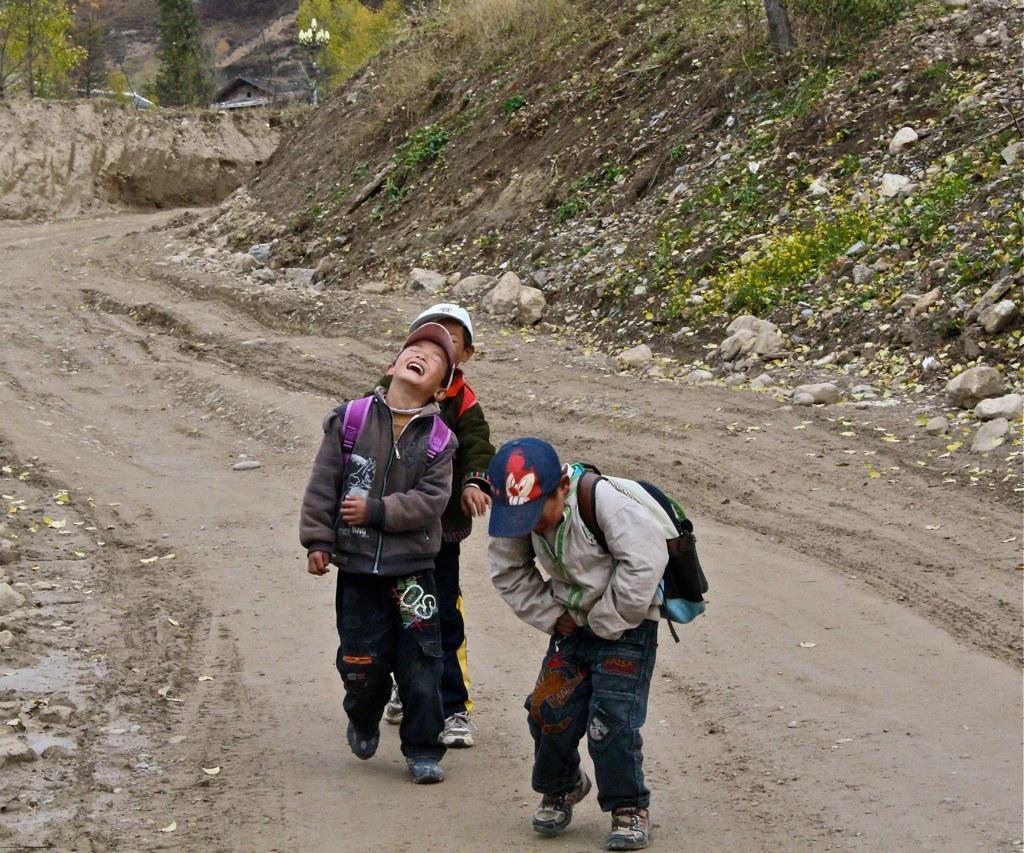How would you summarize this image in a sentence or two? This picture shows three boys carrying backpacks on their back and walking on the road. we see few trees around 